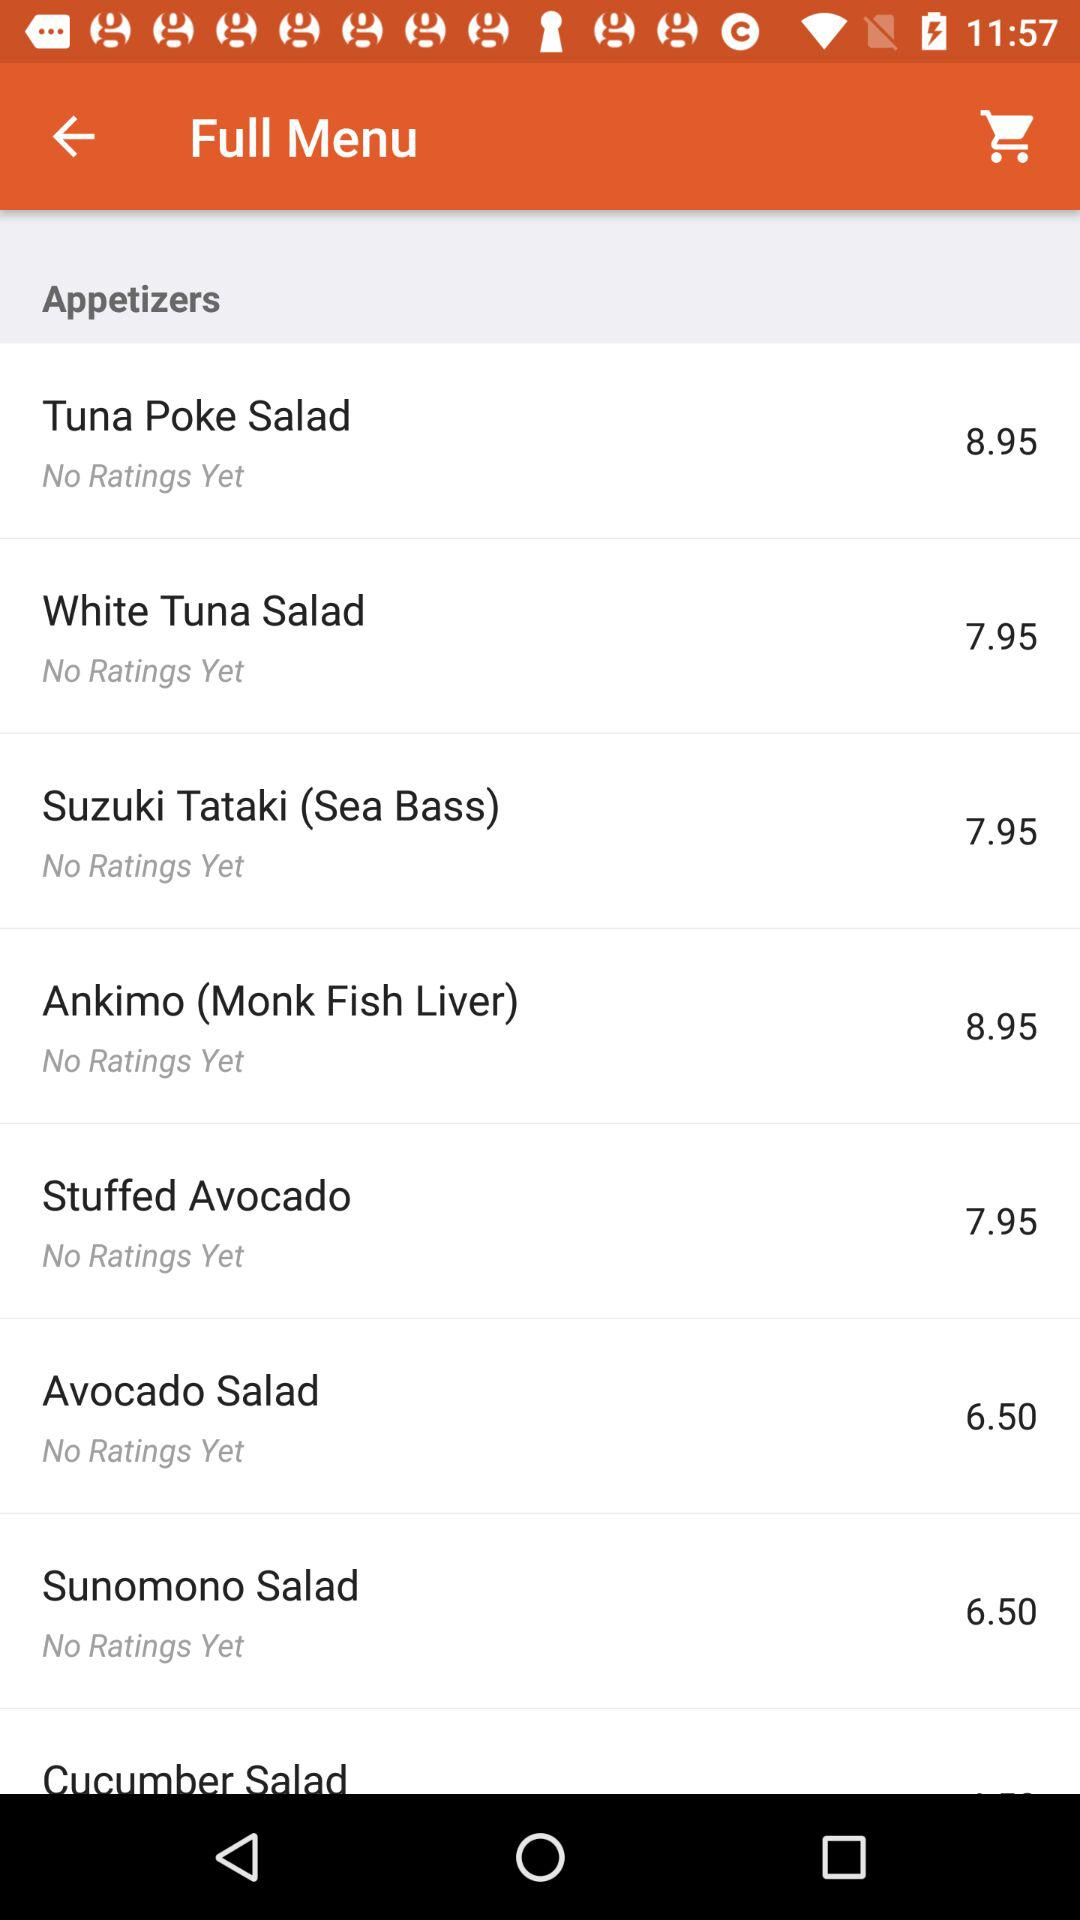What is the price of the tuna poke salad? The price of the tuna poke salad is 8.95. 